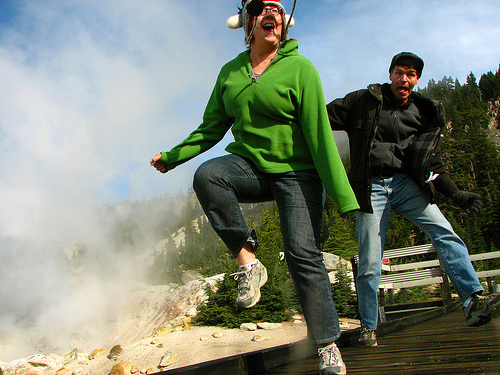<image>
Can you confirm if the girl is behind the man? No. The girl is not behind the man. From this viewpoint, the girl appears to be positioned elsewhere in the scene. 